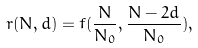<formula> <loc_0><loc_0><loc_500><loc_500>r ( N , d ) = f ( \frac { N } { N _ { 0 } } , \frac { N - 2 d } { N _ { 0 } } ) ,</formula> 